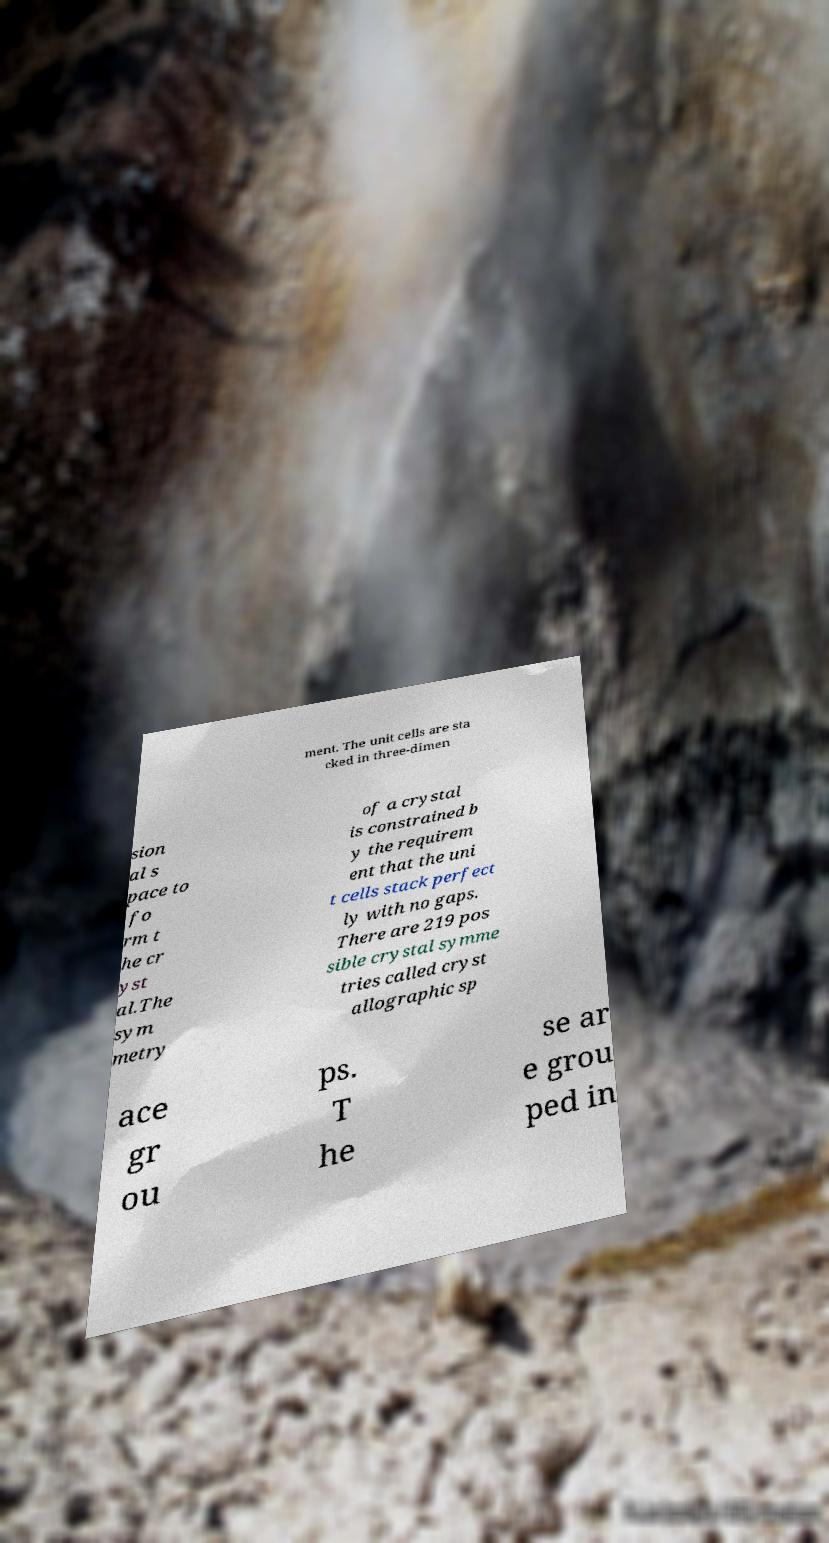I need the written content from this picture converted into text. Can you do that? ment. The unit cells are sta cked in three-dimen sion al s pace to fo rm t he cr yst al.The sym metry of a crystal is constrained b y the requirem ent that the uni t cells stack perfect ly with no gaps. There are 219 pos sible crystal symme tries called cryst allographic sp ace gr ou ps. T he se ar e grou ped in 